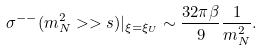<formula> <loc_0><loc_0><loc_500><loc_500>\sigma ^ { - - } ( m _ { N } ^ { 2 } > > s ) | _ { \xi = \xi _ { U } } \sim \frac { 3 2 \pi \beta } { 9 } \frac { 1 } { m _ { N } ^ { 2 } } .</formula> 